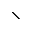<formula> <loc_0><loc_0><loc_500><loc_500>\</formula> 